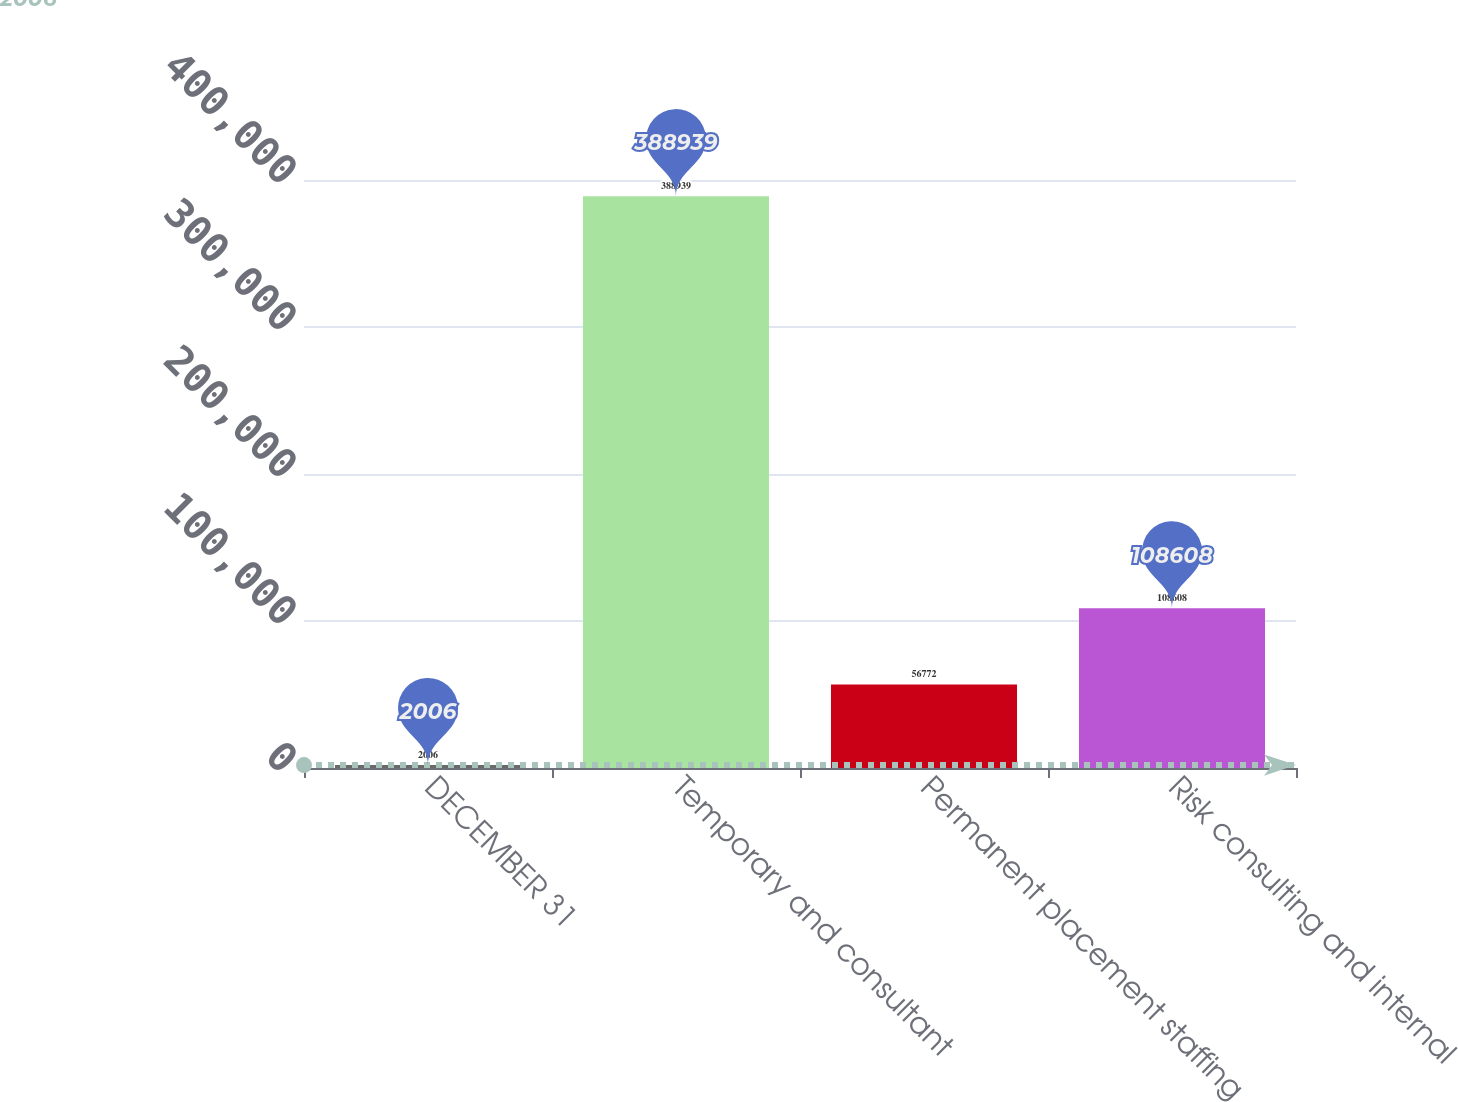Convert chart to OTSL. <chart><loc_0><loc_0><loc_500><loc_500><bar_chart><fcel>DECEMBER 31<fcel>Temporary and consultant<fcel>Permanent placement staffing<fcel>Risk consulting and internal<nl><fcel>2006<fcel>388939<fcel>56772<fcel>108608<nl></chart> 